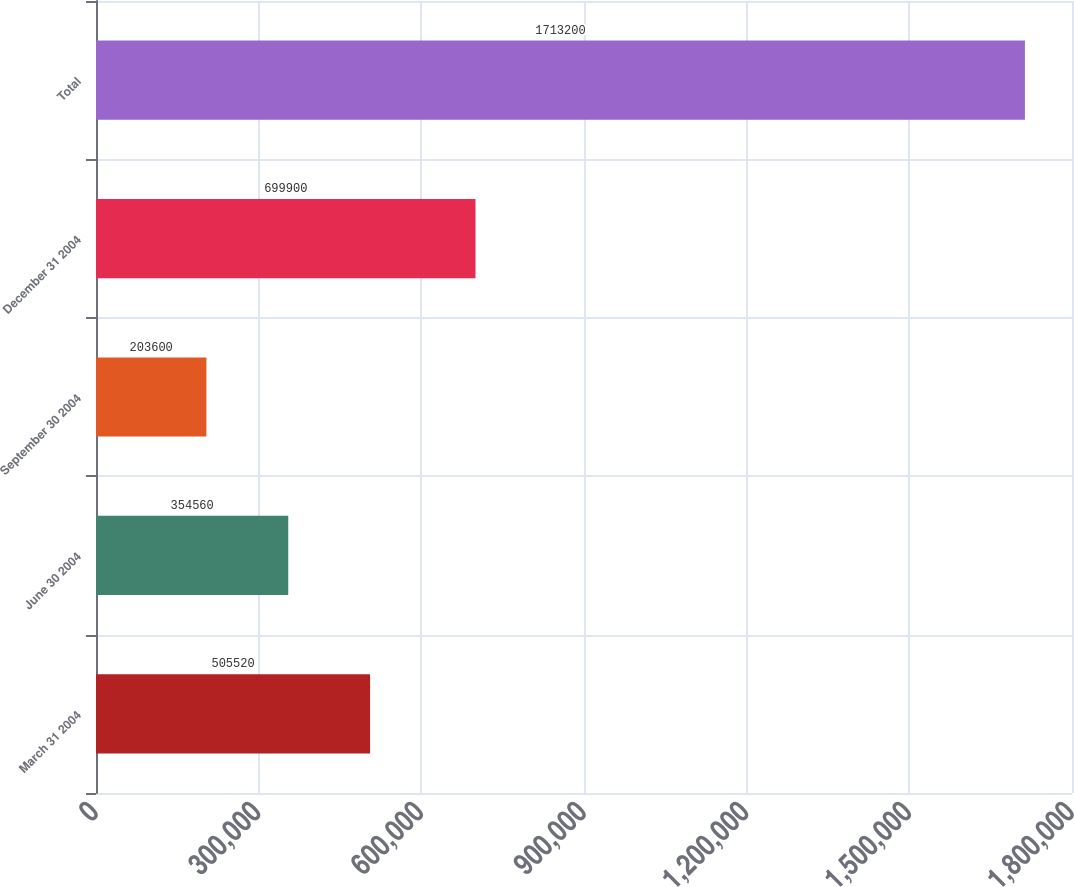Convert chart to OTSL. <chart><loc_0><loc_0><loc_500><loc_500><bar_chart><fcel>March 31 2004<fcel>June 30 2004<fcel>September 30 2004<fcel>December 31 2004<fcel>Total<nl><fcel>505520<fcel>354560<fcel>203600<fcel>699900<fcel>1.7132e+06<nl></chart> 